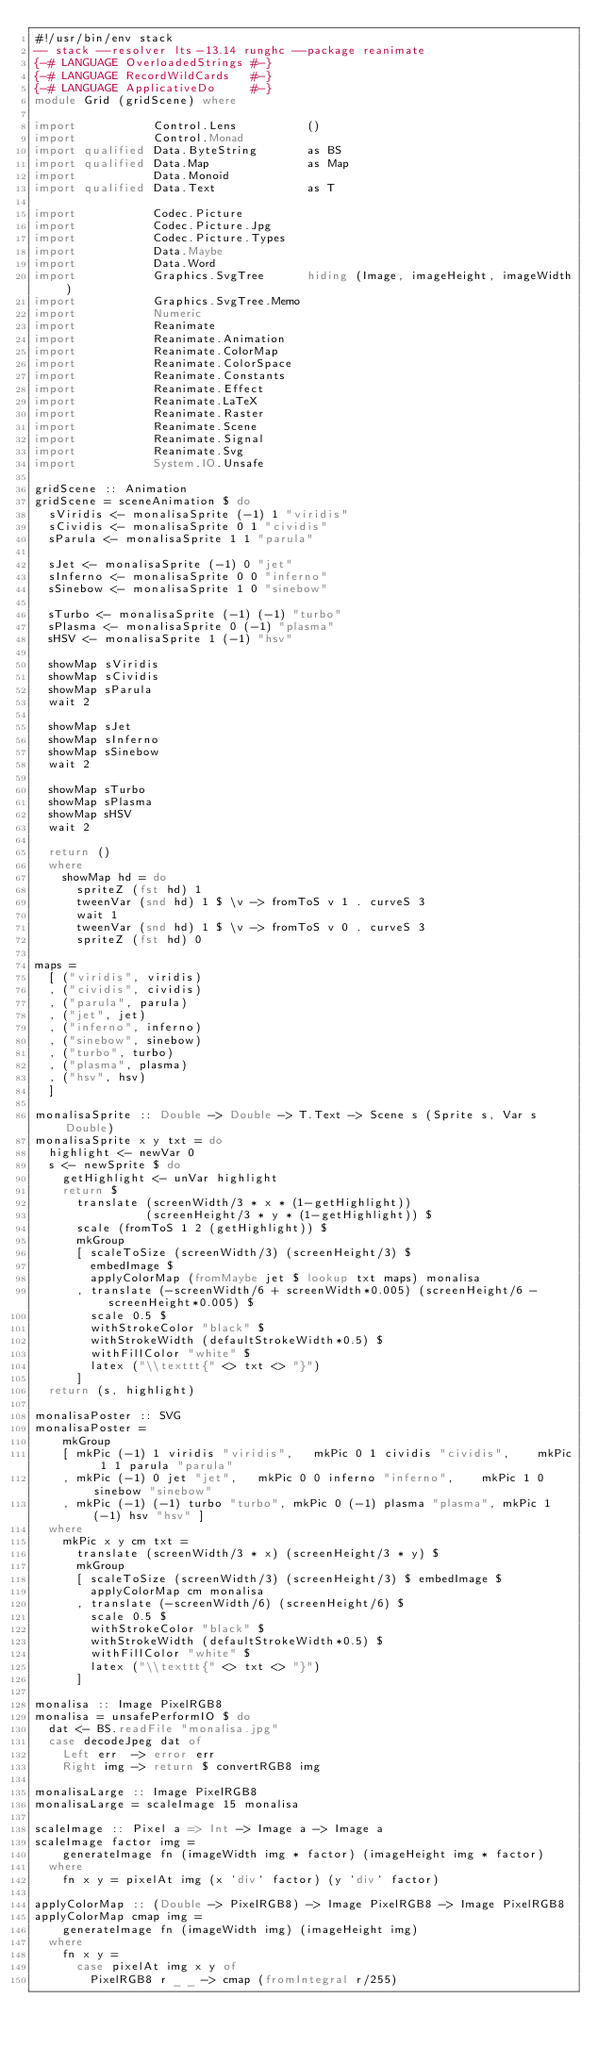<code> <loc_0><loc_0><loc_500><loc_500><_Haskell_>#!/usr/bin/env stack
-- stack --resolver lts-13.14 runghc --package reanimate
{-# LANGUAGE OverloadedStrings #-}
{-# LANGUAGE RecordWildCards   #-}
{-# LANGUAGE ApplicativeDo     #-}
module Grid (gridScene) where

import           Control.Lens          ()
import           Control.Monad
import qualified Data.ByteString       as BS
import qualified Data.Map              as Map
import           Data.Monoid
import qualified Data.Text             as T

import           Codec.Picture
import           Codec.Picture.Jpg
import           Codec.Picture.Types
import           Data.Maybe
import           Data.Word
import           Graphics.SvgTree      hiding (Image, imageHeight, imageWidth)
import           Graphics.SvgTree.Memo
import           Numeric
import           Reanimate
import           Reanimate.Animation
import           Reanimate.ColorMap
import           Reanimate.ColorSpace
import           Reanimate.Constants
import           Reanimate.Effect
import           Reanimate.LaTeX
import           Reanimate.Raster
import           Reanimate.Scene
import           Reanimate.Signal
import           Reanimate.Svg
import           System.IO.Unsafe

gridScene :: Animation
gridScene = sceneAnimation $ do
  sViridis <- monalisaSprite (-1) 1 "viridis"
  sCividis <- monalisaSprite 0 1 "cividis"
  sParula <- monalisaSprite 1 1 "parula"

  sJet <- monalisaSprite (-1) 0 "jet"
  sInferno <- monalisaSprite 0 0 "inferno"
  sSinebow <- monalisaSprite 1 0 "sinebow"

  sTurbo <- monalisaSprite (-1) (-1) "turbo"
  sPlasma <- monalisaSprite 0 (-1) "plasma"
  sHSV <- monalisaSprite 1 (-1) "hsv"

  showMap sViridis
  showMap sCividis
  showMap sParula
  wait 2

  showMap sJet
  showMap sInferno
  showMap sSinebow
  wait 2

  showMap sTurbo
  showMap sPlasma
  showMap sHSV
  wait 2

  return ()
  where
    showMap hd = do
      spriteZ (fst hd) 1
      tweenVar (snd hd) 1 $ \v -> fromToS v 1 . curveS 3
      wait 1
      tweenVar (snd hd) 1 $ \v -> fromToS v 0 . curveS 3
      spriteZ (fst hd) 0

maps =
  [ ("viridis", viridis)
  , ("cividis", cividis)
  , ("parula", parula)
  , ("jet", jet)
  , ("inferno", inferno)
  , ("sinebow", sinebow)
  , ("turbo", turbo)
  , ("plasma", plasma)
  , ("hsv", hsv)
  ]

monalisaSprite :: Double -> Double -> T.Text -> Scene s (Sprite s, Var s Double)
monalisaSprite x y txt = do
  highlight <- newVar 0
  s <- newSprite $ do
    getHighlight <- unVar highlight
    return $
      translate (screenWidth/3 * x * (1-getHighlight))
                (screenHeight/3 * y * (1-getHighlight)) $
      scale (fromToS 1 2 (getHighlight)) $
      mkGroup
      [ scaleToSize (screenWidth/3) (screenHeight/3) $
        embedImage $
        applyColorMap (fromMaybe jet $ lookup txt maps) monalisa
      , translate (-screenWidth/6 + screenWidth*0.005) (screenHeight/6 - screenHeight*0.005) $
        scale 0.5 $
        withStrokeColor "black" $
        withStrokeWidth (defaultStrokeWidth*0.5) $
        withFillColor "white" $
        latex ("\\texttt{" <> txt <> "}")
      ]
  return (s, highlight)

monalisaPoster :: SVG
monalisaPoster =
    mkGroup
    [ mkPic (-1) 1 viridis "viridis",   mkPic 0 1 cividis "cividis",    mkPic 1 1 parula "parula"
    , mkPic (-1) 0 jet "jet",   mkPic 0 0 inferno "inferno",    mkPic 1 0 sinebow "sinebow"
    , mkPic (-1) (-1) turbo "turbo", mkPic 0 (-1) plasma "plasma", mkPic 1 (-1) hsv "hsv" ]
  where
    mkPic x y cm txt =
      translate (screenWidth/3 * x) (screenHeight/3 * y) $
      mkGroup
      [ scaleToSize (screenWidth/3) (screenHeight/3) $ embedImage $
        applyColorMap cm monalisa
      , translate (-screenWidth/6) (screenHeight/6) $
        scale 0.5 $
        withStrokeColor "black" $
        withStrokeWidth (defaultStrokeWidth*0.5) $
        withFillColor "white" $
        latex ("\\texttt{" <> txt <> "}")
      ]

monalisa :: Image PixelRGB8
monalisa = unsafePerformIO $ do
  dat <- BS.readFile "monalisa.jpg"
  case decodeJpeg dat of
    Left err  -> error err
    Right img -> return $ convertRGB8 img

monalisaLarge :: Image PixelRGB8
monalisaLarge = scaleImage 15 monalisa

scaleImage :: Pixel a => Int -> Image a -> Image a
scaleImage factor img =
    generateImage fn (imageWidth img * factor) (imageHeight img * factor)
  where
    fn x y = pixelAt img (x `div` factor) (y `div` factor)

applyColorMap :: (Double -> PixelRGB8) -> Image PixelRGB8 -> Image PixelRGB8
applyColorMap cmap img =
    generateImage fn (imageWidth img) (imageHeight img)
  where
    fn x y =
      case pixelAt img x y of
        PixelRGB8 r _ _ -> cmap (fromIntegral r/255)
</code> 